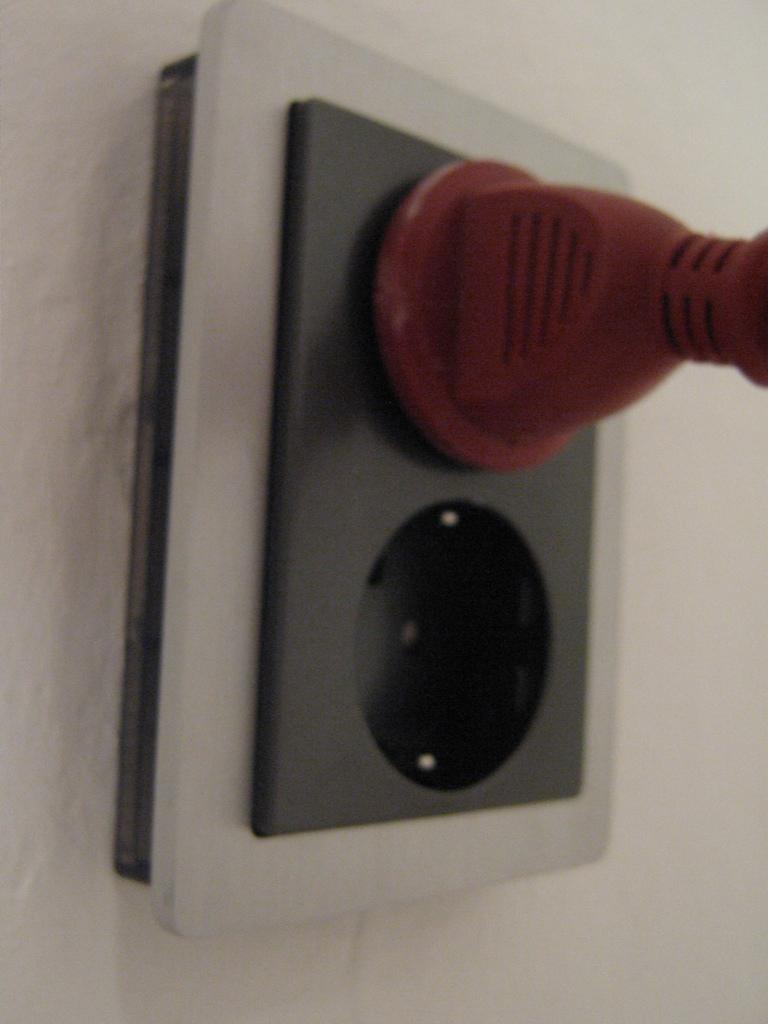What can be found on a wall in the image? There is a socket on a wall in the image. What is the socket used for? The socket is used for connecting electrical devices. Is there any electrical device visible in the image? Yes, there is an electric plug in the image. Where is the guide placed in the image? There is no guide present in the image. What type of ground can be seen in the image? The image does not show any ground; it only shows a socket on a wall and an electric plug. 